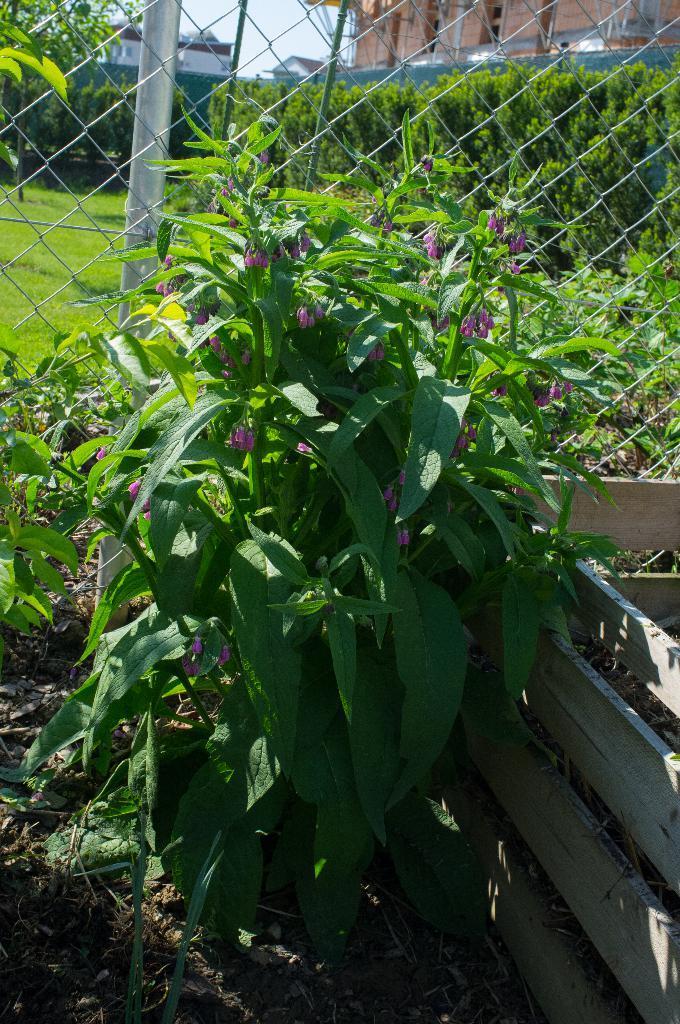How would you summarize this image in a sentence or two? This picture is clicked outside. In the foreground we can see the plants, soil and the wooden planks and we can see the mesh and the metal rod. In the center we can see the green grass, plants, metal rods and some objects. In the background we can see the sky and the buildings. 